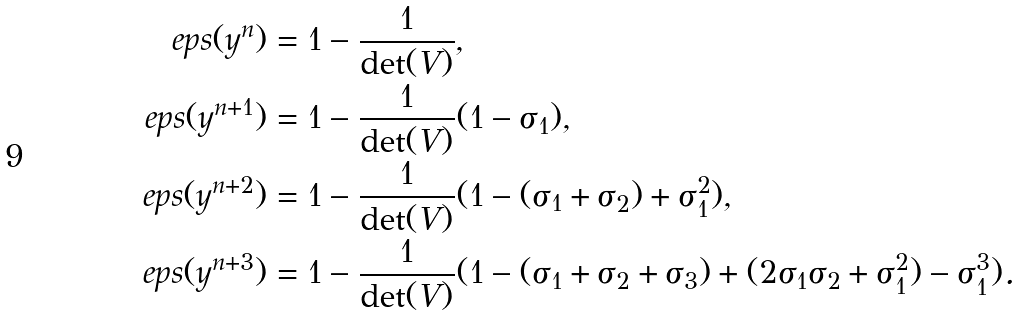Convert formula to latex. <formula><loc_0><loc_0><loc_500><loc_500>\ e p s ( y ^ { n } ) & = 1 - \frac { 1 } { \det ( V ) } , \\ \ e p s ( y ^ { n + 1 } ) & = 1 - \frac { 1 } { \det ( V ) } ( 1 - \sigma _ { 1 } ) , \\ \ e p s ( y ^ { n + 2 } ) & = 1 - \frac { 1 } { \det ( V ) } ( 1 - ( \sigma _ { 1 } + \sigma _ { 2 } ) + \sigma _ { 1 } ^ { 2 } ) , \\ \ e p s ( y ^ { n + 3 } ) & = 1 - \frac { 1 } { \det ( V ) } ( 1 - ( \sigma _ { 1 } + \sigma _ { 2 } + \sigma _ { 3 } ) + ( 2 \sigma _ { 1 } \sigma _ { 2 } + \sigma _ { 1 } ^ { 2 } ) - \sigma _ { 1 } ^ { 3 } ) .</formula> 